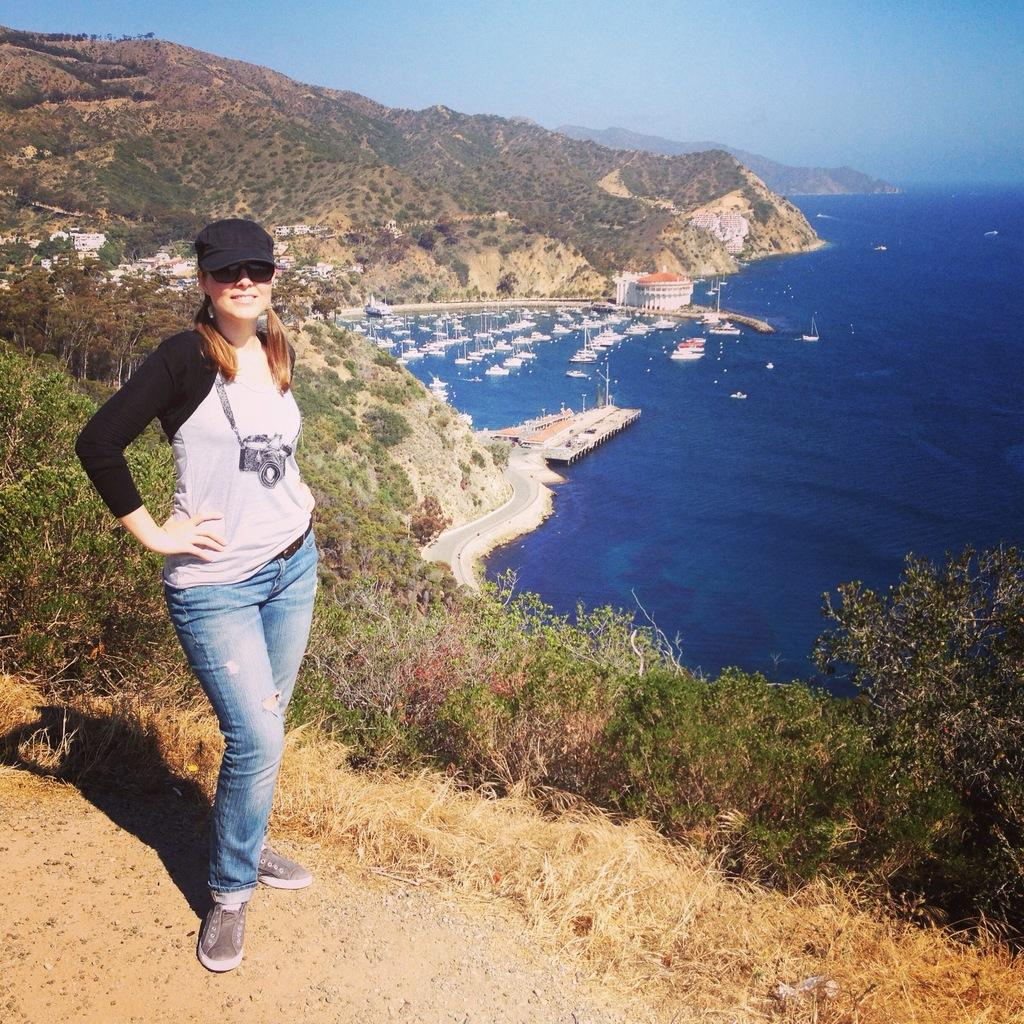What is the lady in the image doing? The lady is standing on the ground in the image. What can be seen in the background of the image? There are mountains with trees and a sea visible in the background of the image. Are there any objects or structures in the sea? Yes, there are ships in the sea. What type of produce is the lady holding in the image? There is no produce visible in the image; the lady is simply standing on the ground. 